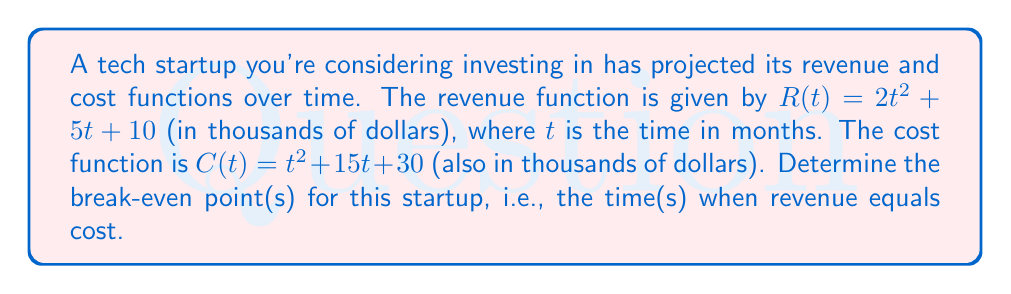Help me with this question. To find the break-even point(s), we need to solve the equation where revenue equals cost:

$R(t) = C(t)$

Substituting the given functions:

$2t^2 + 5t + 10 = t^2 + 15t + 30$

Rearranging the equation to standard form:

$t^2 - 10t - 20 = 0$

This is a quadratic equation. We can solve it using the quadratic formula:

$t = \frac{-b \pm \sqrt{b^2 - 4ac}}{2a}$

Where $a = 1$, $b = -10$, and $c = -20$

Substituting these values:

$t = \frac{10 \pm \sqrt{(-10)^2 - 4(1)(-20)}}{2(1)}$

$t = \frac{10 \pm \sqrt{100 + 80}}{2}$

$t = \frac{10 \pm \sqrt{180}}{2}$

$t = \frac{10 \pm 6\sqrt{5}}{2}$

Simplifying:

$t = 5 \pm 3\sqrt{5}$

This gives us two solutions:

$t_1 = 5 + 3\sqrt{5} \approx 11.71$ months
$t_2 = 5 - 3\sqrt{5} \approx -1.71$ months

Since time cannot be negative in this context, we discard the negative solution.
Answer: The break-even point occurs at approximately 11.71 months. 